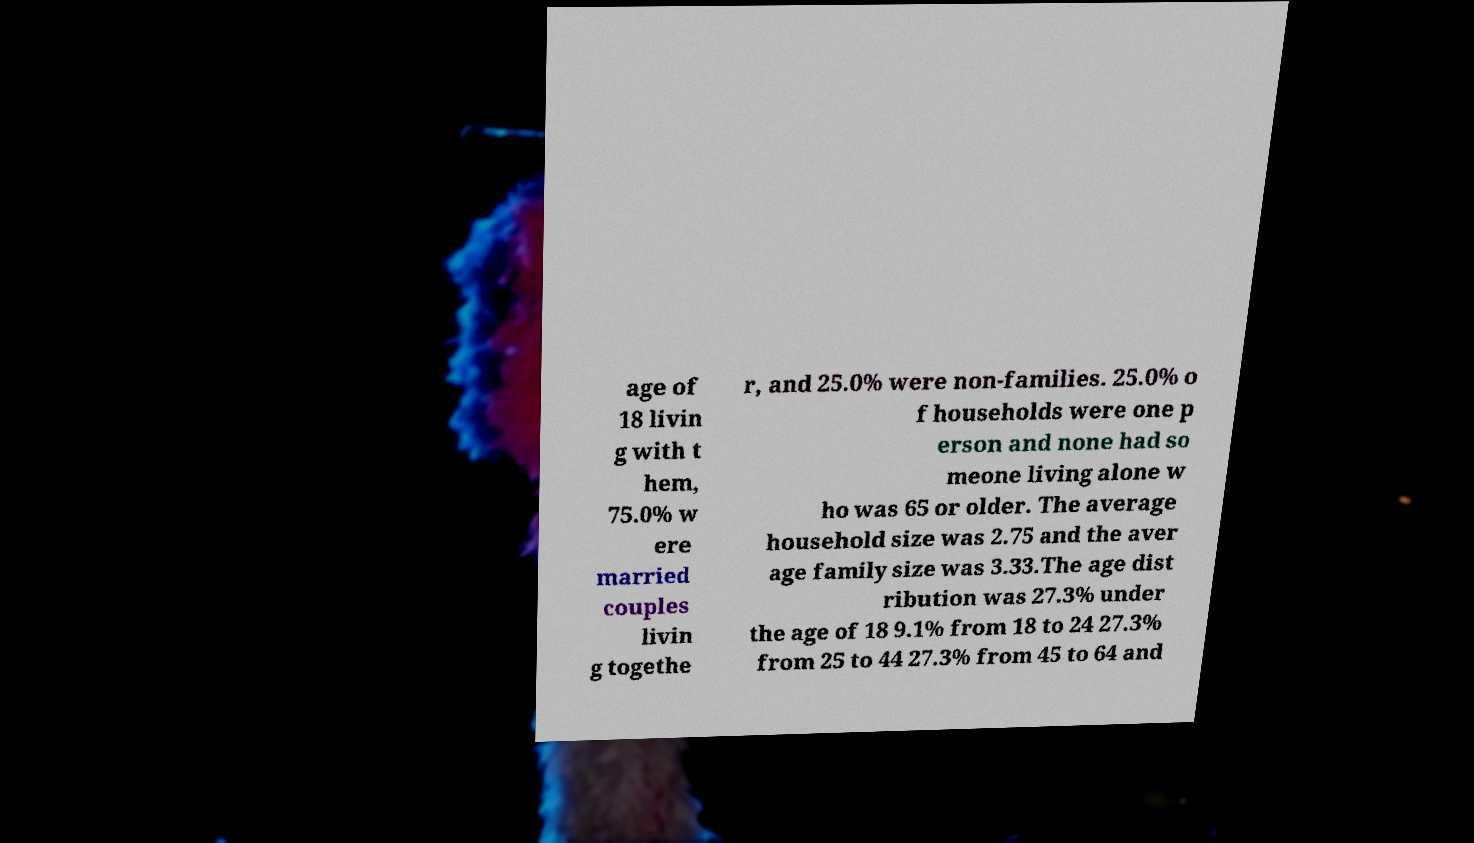Could you assist in decoding the text presented in this image and type it out clearly? age of 18 livin g with t hem, 75.0% w ere married couples livin g togethe r, and 25.0% were non-families. 25.0% o f households were one p erson and none had so meone living alone w ho was 65 or older. The average household size was 2.75 and the aver age family size was 3.33.The age dist ribution was 27.3% under the age of 18 9.1% from 18 to 24 27.3% from 25 to 44 27.3% from 45 to 64 and 